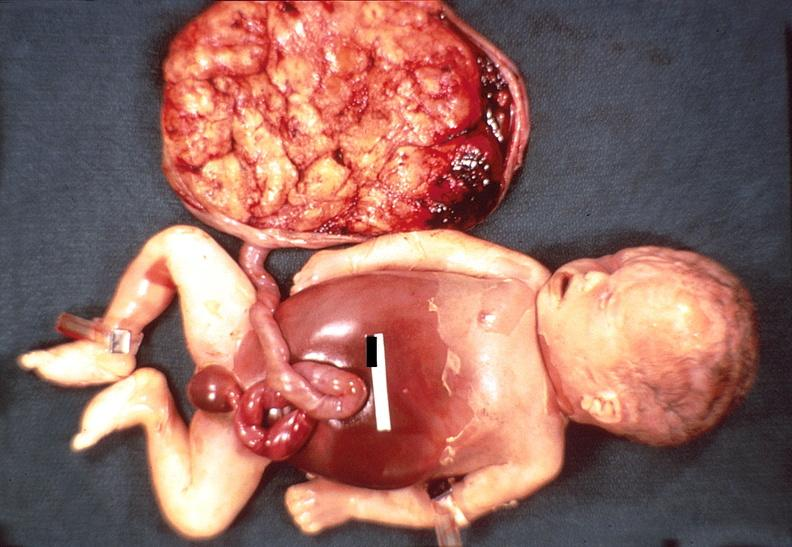does cachexia show hemolytic disease of newborn?
Answer the question using a single word or phrase. No 